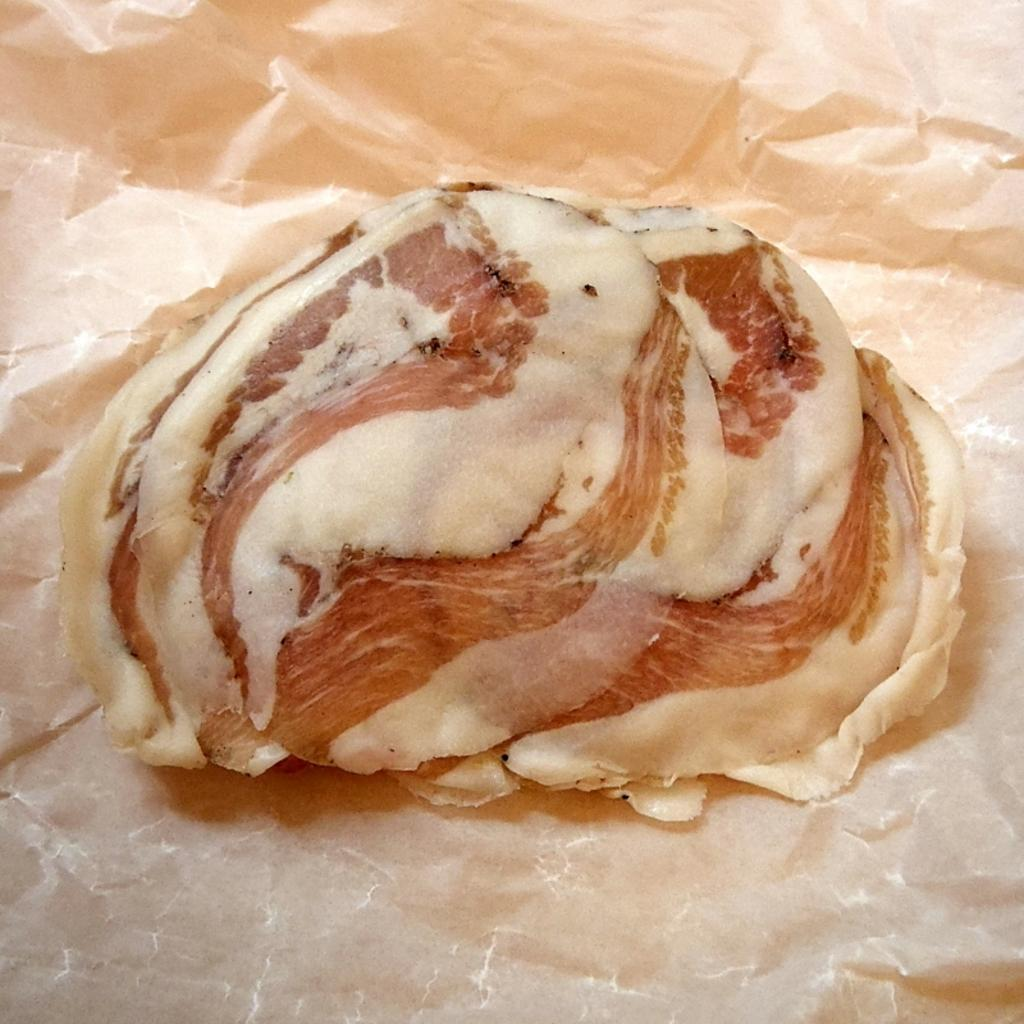What is present in the image that people typically consume? There is food in the image. How is the food being served or presented? The food is on a paper. What type of lock can be seen securing the food in the image? There is no lock present in the image; the food is on a paper. What kind of music is playing in the background of the image? There is no music present in the image; it only features food on a paper. 